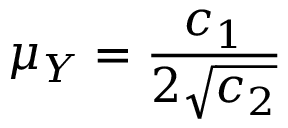Convert formula to latex. <formula><loc_0><loc_0><loc_500><loc_500>\mu _ { Y } = \frac { c _ { 1 } } { 2 \sqrt { c _ { 2 } } }</formula> 